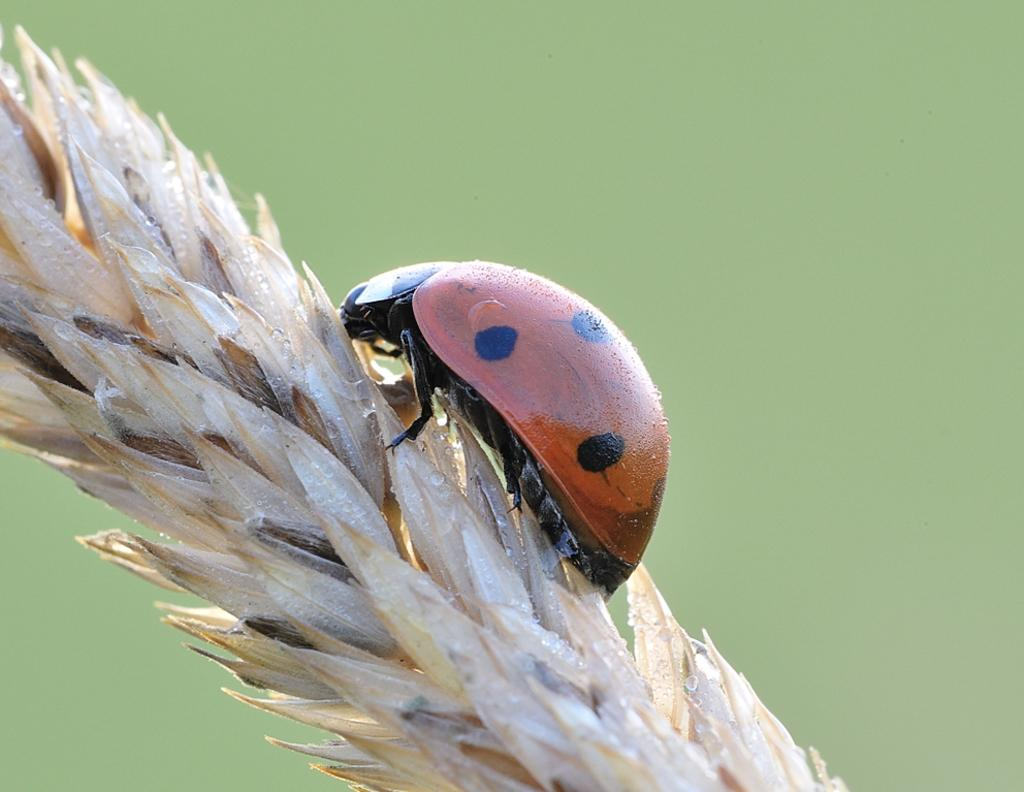What is present in the image? There is an insect in the image. Where is the insect located? The insect is on a wheat plant. What can be observed about the background of the image? The background has a light green color. How many cakes are being served to the family by the cow in the image? There is no cow or cake present in the image; it features an insect on a wheat plant with a light green background. 